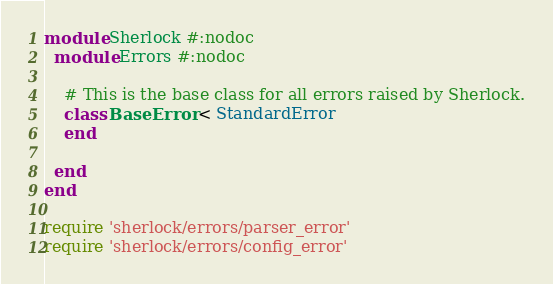<code> <loc_0><loc_0><loc_500><loc_500><_Ruby_>
module Sherlock #:nodoc
  module Errors #:nodoc

    # This is the base class for all errors raised by Sherlock.
    class BaseError < StandardError
    end

  end
end

require 'sherlock/errors/parser_error'
require 'sherlock/errors/config_error'
</code> 